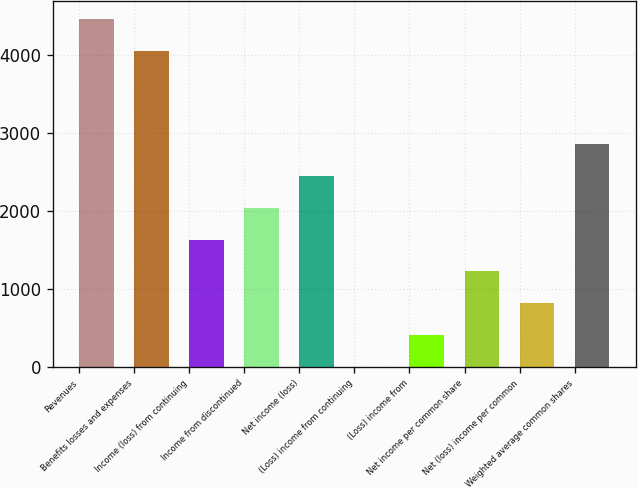Convert chart to OTSL. <chart><loc_0><loc_0><loc_500><loc_500><bar_chart><fcel>Revenues<fcel>Benefits losses and expenses<fcel>Income (loss) from continuing<fcel>Income from discontinued<fcel>Net income (loss)<fcel>(Loss) income from continuing<fcel>(Loss) income from<fcel>Net income per common share<fcel>Net (loss) income per common<fcel>Weighted average common shares<nl><fcel>4468.48<fcel>4060<fcel>1634.16<fcel>2042.64<fcel>2451.12<fcel>0.25<fcel>408.73<fcel>1225.68<fcel>817.21<fcel>2859.59<nl></chart> 